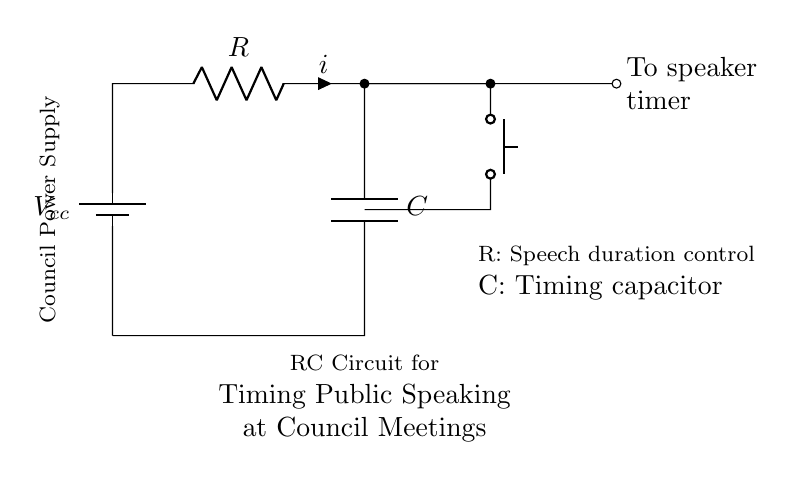What is the type of the circuit? This circuit is an RC (Resistor-Capacitor) circuit, which is commonly used for timing applications. This is evident from the presence of a resistor and a capacitor connected in series, forming the basis for timing functions.
Answer: RC circuit What component controls the speech duration? The resistor controls the speech duration, as indicated in the diagram by its label. In RC circuits, the resistance affects the charging and discharging time of the capacitor, thus influencing timing.
Answer: Resistor What is connected to the timing capacitor? The speech duration control is connected to the timing capacitor. This implies the capacitor's role in timing, as it helps determine how long the speech will last based on its charge and discharge cycle.
Answer: To speaker timer What does the push button do in this circuit? The push button acts as a manual control to initiate the timing function of the circuit. When pressed, it allows current to flow, thus influencing the capacitor's charging state and timing process, indicating real-time control over the timing.
Answer: Initiates timing How does the capacitance value affect timing? The capacitance value directly impacts the time constant of the circuit, which is calculated as the product of resistance and capacitance. A higher capacitance results in a longer charging time for the capacitor, thus prolonging the event timing.
Answer: Prolongs timing What is the function of the battery in this RC circuit? The battery provides the necessary voltage supply for the circuit, which powers the components. In the diagram, the label indicates it serves as the council power supply, ensuring that the circuit operates correctly.
Answer: Power supply 